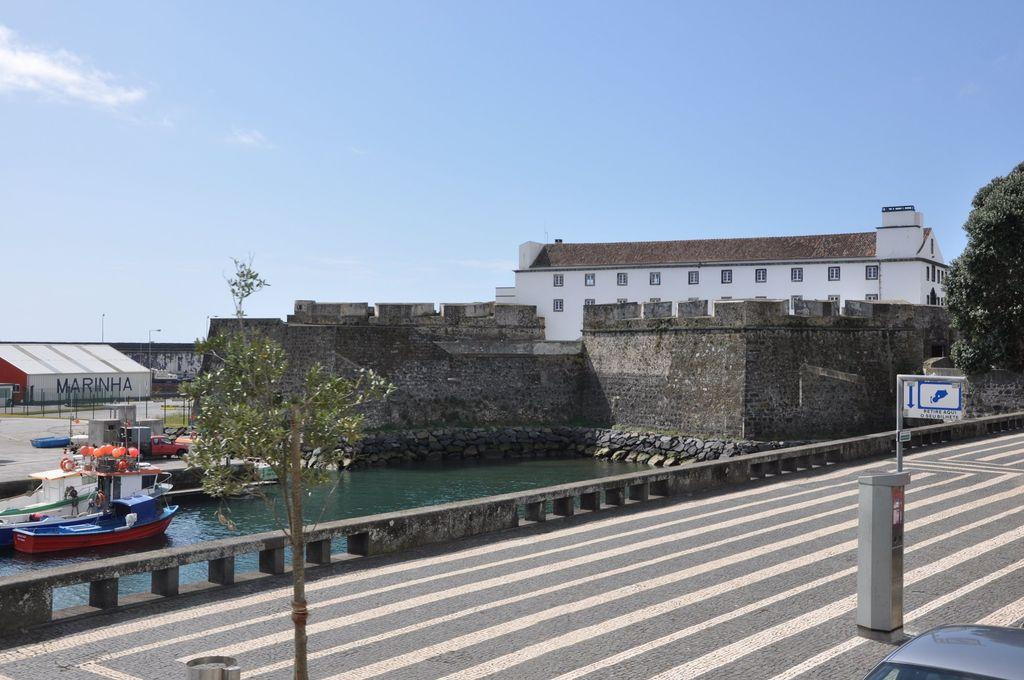What type of structure is present in the image? There is a building with windows in the image. What natural element can be seen in the image? There is a tree in the image. What body of water is visible in the image? There is water visible in the image. What part of the natural environment is visible in the image? The sky is visible in the image. What mode of transportation is present in the image? There is a boat in the image. What man-made feature can be seen in the image? There is a road in the image. What type of winter sport is being played on the road in the image? There is no winter sport or any indication of winter in the image; it features a building, a tree, water, sky, a boat, and a road. How many balls are visible in the image? There are no balls present in the image. 